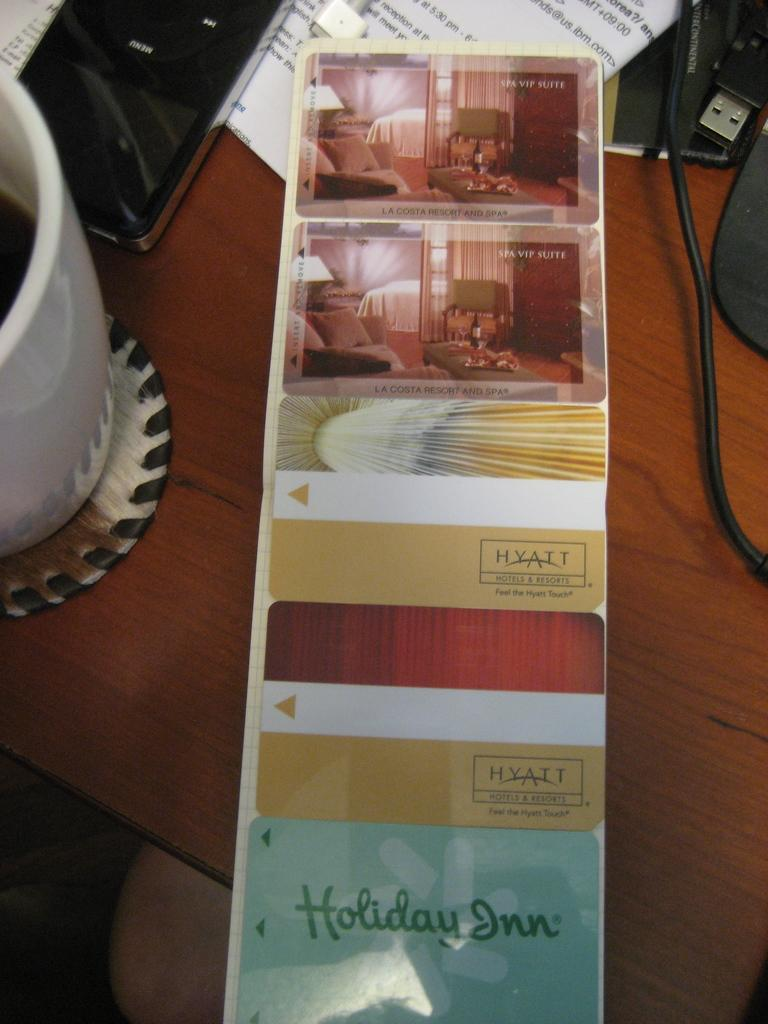What is on the wooden surface in the image? There is a paper with images, a cup, a mobile, a wire, and other unspecified items on the wooden surface. Can you describe the paper with images? The paper with images is on the wooden surface. What is the cup used for? The purpose of the cup cannot be determined from the image, but it is likely used for holding liquids. What is the wire connected to? The image does not show what the wire is connected to. How many items can be seen on the wooden surface? There are at least six items visible on the wooden surface: a paper with images, a cup, a mobile, a wire, and two unspecified items. What type of potato is being grown in the country shown in the image? There is no country or potato present in the image; it features a paper with images, a cup, a mobile, a wire, and other unspecified items on a wooden surface. 